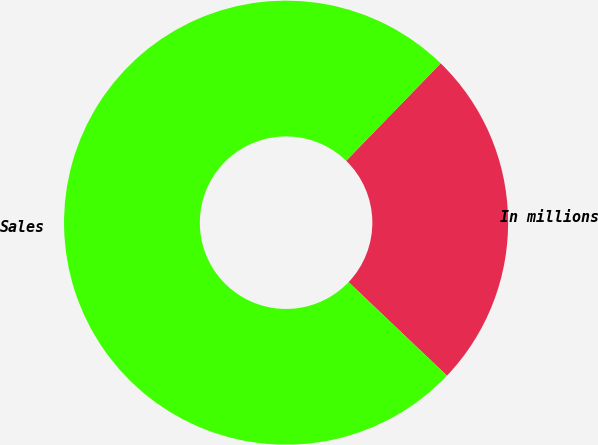Convert chart. <chart><loc_0><loc_0><loc_500><loc_500><pie_chart><fcel>In millions<fcel>Sales<nl><fcel>24.84%<fcel>75.16%<nl></chart> 